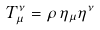<formula> <loc_0><loc_0><loc_500><loc_500>T _ { \mu } ^ { \nu } = \rho \, \eta _ { \mu } \eta ^ { \nu }</formula> 